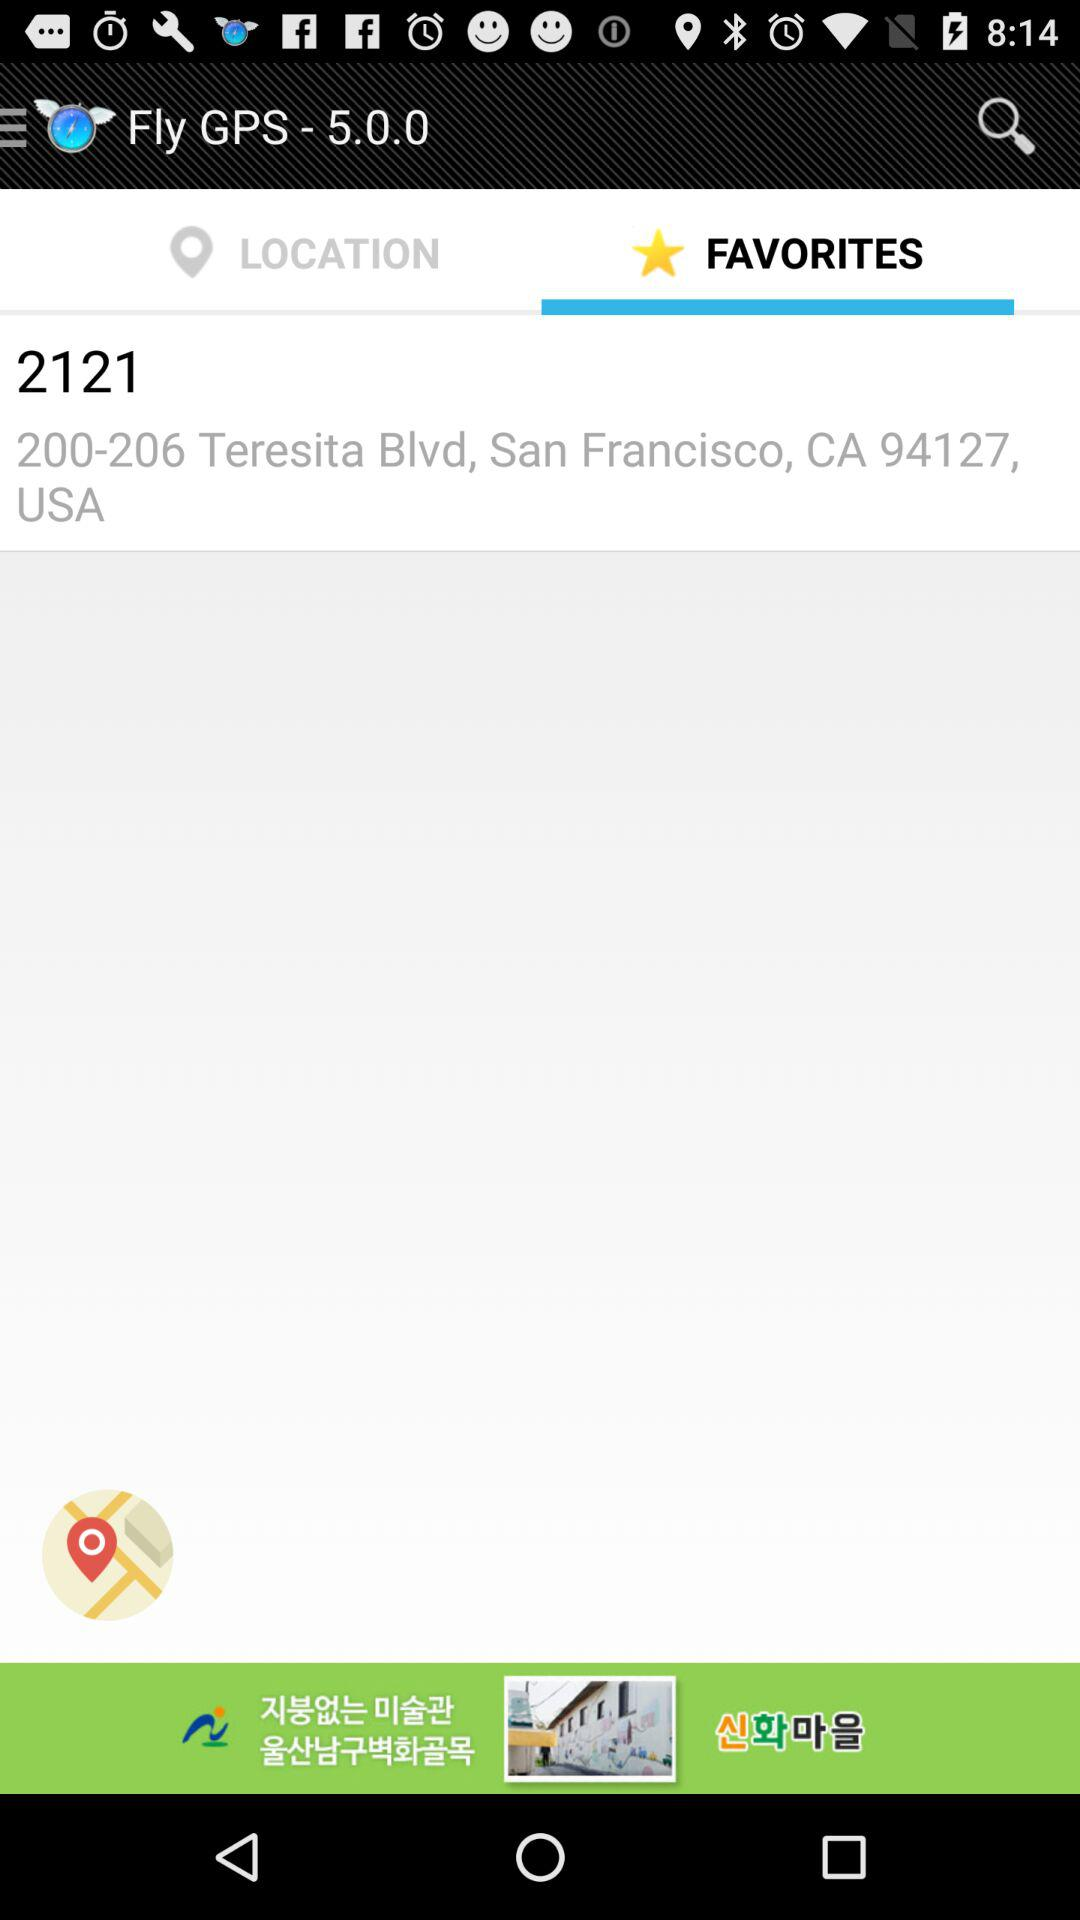What is the address mentioned in favorites? The mentioned address is 2121, 200-206 Teresita Blvd, San Francisco, CA 94127, USA. 